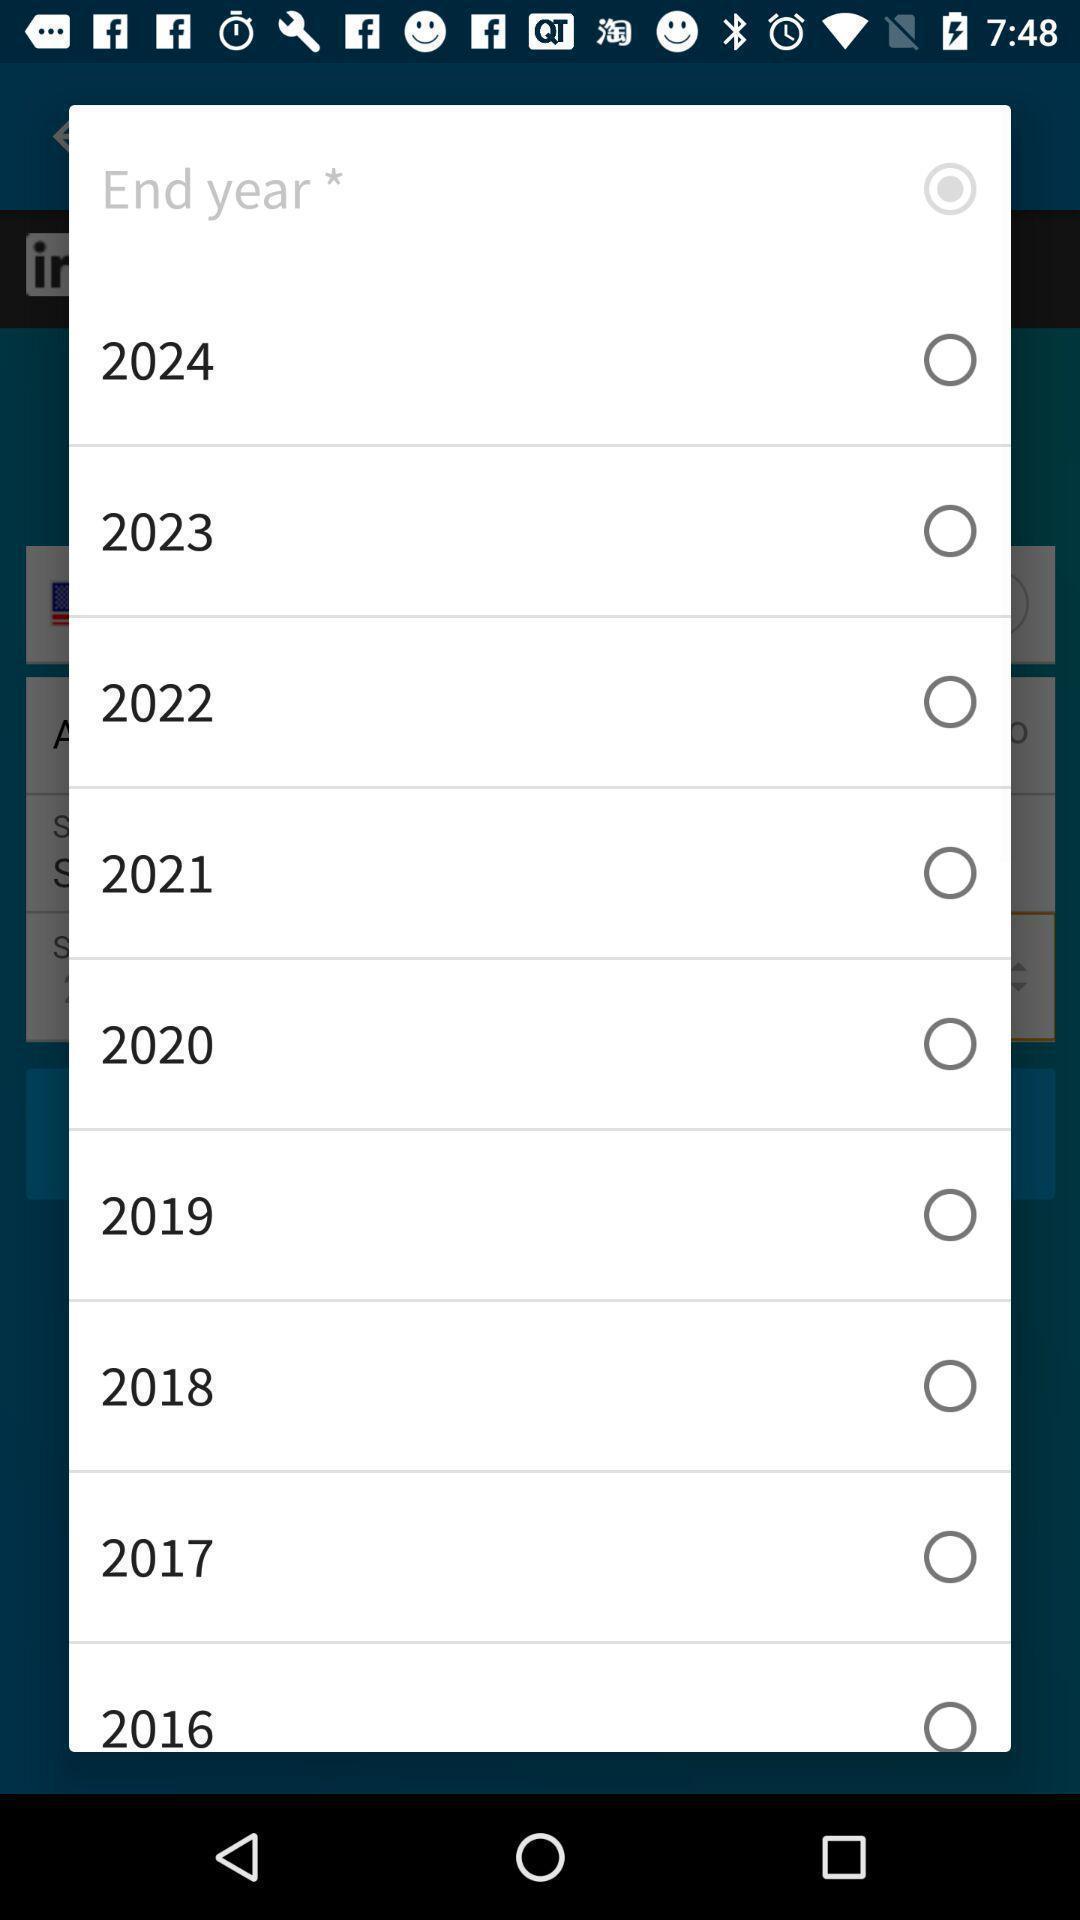What is the overall content of this screenshot? Pop-up displaying various years to select in a learning app. 